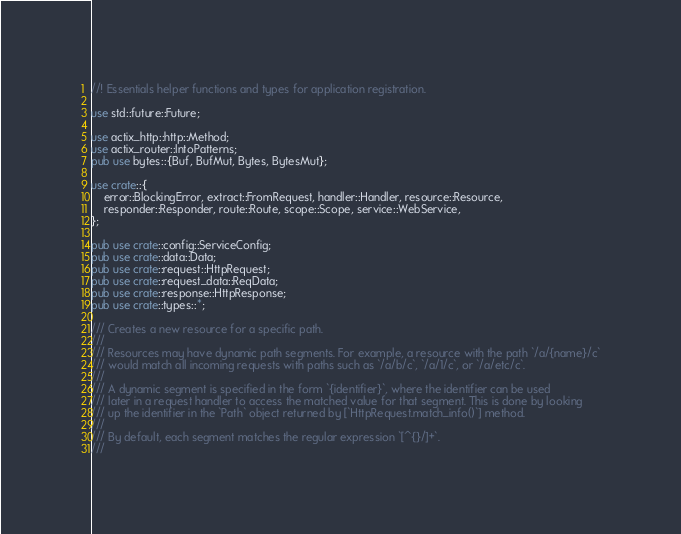<code> <loc_0><loc_0><loc_500><loc_500><_Rust_>//! Essentials helper functions and types for application registration.

use std::future::Future;

use actix_http::http::Method;
use actix_router::IntoPatterns;
pub use bytes::{Buf, BufMut, Bytes, BytesMut};

use crate::{
    error::BlockingError, extract::FromRequest, handler::Handler, resource::Resource,
    responder::Responder, route::Route, scope::Scope, service::WebService,
};

pub use crate::config::ServiceConfig;
pub use crate::data::Data;
pub use crate::request::HttpRequest;
pub use crate::request_data::ReqData;
pub use crate::response::HttpResponse;
pub use crate::types::*;

/// Creates a new resource for a specific path.
///
/// Resources may have dynamic path segments. For example, a resource with the path `/a/{name}/c`
/// would match all incoming requests with paths such as `/a/b/c`, `/a/1/c`, or `/a/etc/c`.
///
/// A dynamic segment is specified in the form `{identifier}`, where the identifier can be used
/// later in a request handler to access the matched value for that segment. This is done by looking
/// up the identifier in the `Path` object returned by [`HttpRequest.match_info()`] method.
///
/// By default, each segment matches the regular expression `[^{}/]+`.
///</code> 